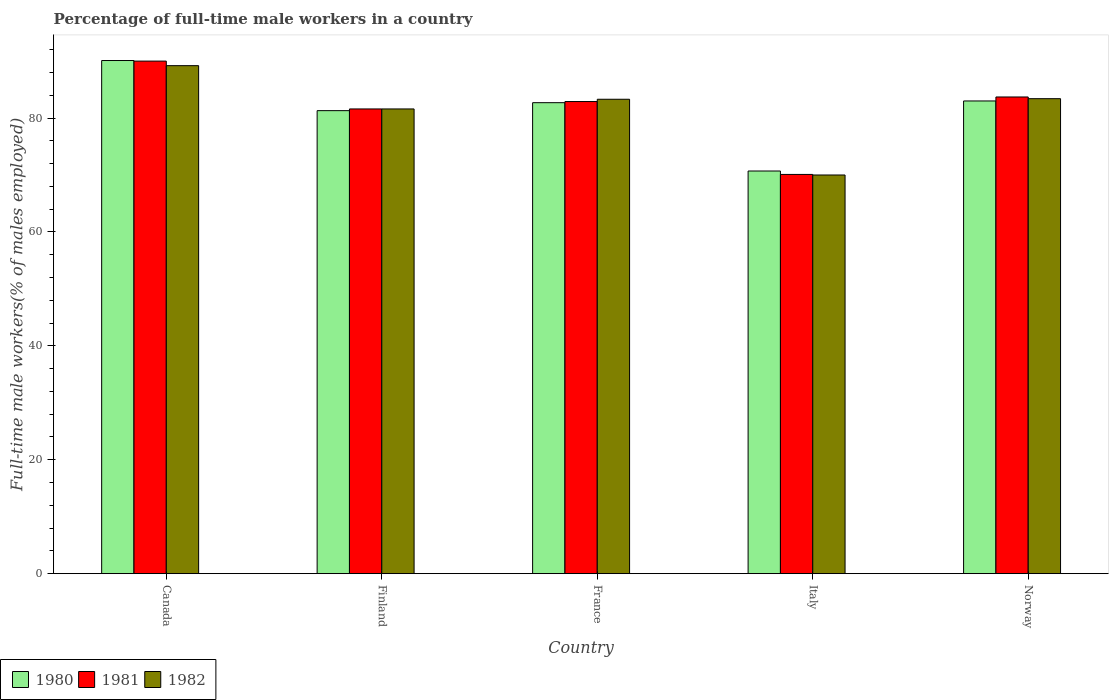How many groups of bars are there?
Your response must be concise. 5. Are the number of bars per tick equal to the number of legend labels?
Provide a succinct answer. Yes. Are the number of bars on each tick of the X-axis equal?
Provide a succinct answer. Yes. How many bars are there on the 1st tick from the right?
Give a very brief answer. 3. In how many cases, is the number of bars for a given country not equal to the number of legend labels?
Give a very brief answer. 0. What is the percentage of full-time male workers in 1982 in Canada?
Offer a very short reply. 89.2. Across all countries, what is the maximum percentage of full-time male workers in 1980?
Ensure brevity in your answer.  90.1. What is the total percentage of full-time male workers in 1980 in the graph?
Provide a short and direct response. 407.8. What is the difference between the percentage of full-time male workers in 1982 in Canada and that in Norway?
Offer a terse response. 5.8. What is the difference between the percentage of full-time male workers in 1981 in France and the percentage of full-time male workers in 1980 in Finland?
Give a very brief answer. 1.6. What is the average percentage of full-time male workers in 1980 per country?
Provide a short and direct response. 81.56. What is the difference between the percentage of full-time male workers of/in 1981 and percentage of full-time male workers of/in 1982 in Italy?
Make the answer very short. 0.1. In how many countries, is the percentage of full-time male workers in 1980 greater than 48 %?
Ensure brevity in your answer.  5. What is the ratio of the percentage of full-time male workers in 1980 in Finland to that in Italy?
Your response must be concise. 1.15. Is the percentage of full-time male workers in 1982 in Finland less than that in Norway?
Offer a very short reply. Yes. What is the difference between the highest and the second highest percentage of full-time male workers in 1980?
Offer a terse response. 7.1. What is the difference between the highest and the lowest percentage of full-time male workers in 1982?
Ensure brevity in your answer.  19.2. In how many countries, is the percentage of full-time male workers in 1981 greater than the average percentage of full-time male workers in 1981 taken over all countries?
Your answer should be very brief. 3. Is the sum of the percentage of full-time male workers in 1980 in Finland and Norway greater than the maximum percentage of full-time male workers in 1981 across all countries?
Provide a short and direct response. Yes. Is it the case that in every country, the sum of the percentage of full-time male workers in 1980 and percentage of full-time male workers in 1982 is greater than the percentage of full-time male workers in 1981?
Keep it short and to the point. Yes. Are all the bars in the graph horizontal?
Ensure brevity in your answer.  No. How many countries are there in the graph?
Offer a very short reply. 5. Does the graph contain grids?
Your answer should be compact. No. How many legend labels are there?
Ensure brevity in your answer.  3. How are the legend labels stacked?
Your response must be concise. Horizontal. What is the title of the graph?
Your answer should be compact. Percentage of full-time male workers in a country. What is the label or title of the X-axis?
Your answer should be very brief. Country. What is the label or title of the Y-axis?
Give a very brief answer. Full-time male workers(% of males employed). What is the Full-time male workers(% of males employed) in 1980 in Canada?
Your answer should be compact. 90.1. What is the Full-time male workers(% of males employed) in 1982 in Canada?
Ensure brevity in your answer.  89.2. What is the Full-time male workers(% of males employed) in 1980 in Finland?
Provide a short and direct response. 81.3. What is the Full-time male workers(% of males employed) in 1981 in Finland?
Make the answer very short. 81.6. What is the Full-time male workers(% of males employed) of 1982 in Finland?
Make the answer very short. 81.6. What is the Full-time male workers(% of males employed) of 1980 in France?
Your response must be concise. 82.7. What is the Full-time male workers(% of males employed) in 1981 in France?
Offer a very short reply. 82.9. What is the Full-time male workers(% of males employed) of 1982 in France?
Your answer should be compact. 83.3. What is the Full-time male workers(% of males employed) of 1980 in Italy?
Your answer should be compact. 70.7. What is the Full-time male workers(% of males employed) in 1981 in Italy?
Provide a succinct answer. 70.1. What is the Full-time male workers(% of males employed) in 1982 in Italy?
Ensure brevity in your answer.  70. What is the Full-time male workers(% of males employed) of 1981 in Norway?
Offer a very short reply. 83.7. What is the Full-time male workers(% of males employed) in 1982 in Norway?
Give a very brief answer. 83.4. Across all countries, what is the maximum Full-time male workers(% of males employed) in 1980?
Offer a terse response. 90.1. Across all countries, what is the maximum Full-time male workers(% of males employed) in 1982?
Keep it short and to the point. 89.2. Across all countries, what is the minimum Full-time male workers(% of males employed) in 1980?
Keep it short and to the point. 70.7. Across all countries, what is the minimum Full-time male workers(% of males employed) in 1981?
Give a very brief answer. 70.1. What is the total Full-time male workers(% of males employed) in 1980 in the graph?
Offer a very short reply. 407.8. What is the total Full-time male workers(% of males employed) of 1981 in the graph?
Ensure brevity in your answer.  408.3. What is the total Full-time male workers(% of males employed) of 1982 in the graph?
Make the answer very short. 407.5. What is the difference between the Full-time male workers(% of males employed) in 1980 in Canada and that in Finland?
Provide a succinct answer. 8.8. What is the difference between the Full-time male workers(% of males employed) of 1981 in Canada and that in Finland?
Make the answer very short. 8.4. What is the difference between the Full-time male workers(% of males employed) in 1981 in Canada and that in France?
Provide a succinct answer. 7.1. What is the difference between the Full-time male workers(% of males employed) in 1982 in Canada and that in France?
Ensure brevity in your answer.  5.9. What is the difference between the Full-time male workers(% of males employed) of 1982 in Finland and that in France?
Your answer should be very brief. -1.7. What is the difference between the Full-time male workers(% of males employed) in 1980 in Finland and that in Italy?
Ensure brevity in your answer.  10.6. What is the difference between the Full-time male workers(% of males employed) in 1982 in Finland and that in Italy?
Your answer should be very brief. 11.6. What is the difference between the Full-time male workers(% of males employed) of 1980 in Finland and that in Norway?
Offer a very short reply. -1.7. What is the difference between the Full-time male workers(% of males employed) in 1981 in Finland and that in Norway?
Keep it short and to the point. -2.1. What is the difference between the Full-time male workers(% of males employed) in 1982 in Finland and that in Norway?
Keep it short and to the point. -1.8. What is the difference between the Full-time male workers(% of males employed) of 1980 in France and that in Italy?
Your answer should be compact. 12. What is the difference between the Full-time male workers(% of males employed) in 1982 in France and that in Italy?
Your response must be concise. 13.3. What is the difference between the Full-time male workers(% of males employed) of 1980 in Italy and that in Norway?
Keep it short and to the point. -12.3. What is the difference between the Full-time male workers(% of males employed) in 1982 in Italy and that in Norway?
Provide a short and direct response. -13.4. What is the difference between the Full-time male workers(% of males employed) in 1980 in Canada and the Full-time male workers(% of males employed) in 1981 in France?
Offer a very short reply. 7.2. What is the difference between the Full-time male workers(% of males employed) in 1980 in Canada and the Full-time male workers(% of males employed) in 1982 in France?
Provide a short and direct response. 6.8. What is the difference between the Full-time male workers(% of males employed) in 1981 in Canada and the Full-time male workers(% of males employed) in 1982 in France?
Keep it short and to the point. 6.7. What is the difference between the Full-time male workers(% of males employed) in 1980 in Canada and the Full-time male workers(% of males employed) in 1981 in Italy?
Offer a terse response. 20. What is the difference between the Full-time male workers(% of males employed) of 1980 in Canada and the Full-time male workers(% of males employed) of 1982 in Italy?
Your response must be concise. 20.1. What is the difference between the Full-time male workers(% of males employed) in 1981 in Canada and the Full-time male workers(% of males employed) in 1982 in Norway?
Offer a terse response. 6.6. What is the difference between the Full-time male workers(% of males employed) of 1980 in Finland and the Full-time male workers(% of males employed) of 1982 in France?
Make the answer very short. -2. What is the difference between the Full-time male workers(% of males employed) in 1980 in Finland and the Full-time male workers(% of males employed) in 1982 in Italy?
Provide a succinct answer. 11.3. What is the difference between the Full-time male workers(% of males employed) in 1981 in Finland and the Full-time male workers(% of males employed) in 1982 in Norway?
Give a very brief answer. -1.8. What is the difference between the Full-time male workers(% of males employed) in 1980 in France and the Full-time male workers(% of males employed) in 1982 in Italy?
Your answer should be very brief. 12.7. What is the difference between the Full-time male workers(% of males employed) in 1981 in France and the Full-time male workers(% of males employed) in 1982 in Italy?
Your response must be concise. 12.9. What is the difference between the Full-time male workers(% of males employed) in 1980 in France and the Full-time male workers(% of males employed) in 1982 in Norway?
Provide a short and direct response. -0.7. What is the average Full-time male workers(% of males employed) in 1980 per country?
Ensure brevity in your answer.  81.56. What is the average Full-time male workers(% of males employed) in 1981 per country?
Provide a succinct answer. 81.66. What is the average Full-time male workers(% of males employed) in 1982 per country?
Give a very brief answer. 81.5. What is the difference between the Full-time male workers(% of males employed) of 1980 and Full-time male workers(% of males employed) of 1981 in Canada?
Offer a terse response. 0.1. What is the difference between the Full-time male workers(% of males employed) of 1980 and Full-time male workers(% of males employed) of 1982 in Canada?
Your response must be concise. 0.9. What is the difference between the Full-time male workers(% of males employed) in 1981 and Full-time male workers(% of males employed) in 1982 in Canada?
Ensure brevity in your answer.  0.8. What is the difference between the Full-time male workers(% of males employed) in 1980 and Full-time male workers(% of males employed) in 1981 in Finland?
Your answer should be very brief. -0.3. What is the difference between the Full-time male workers(% of males employed) of 1981 and Full-time male workers(% of males employed) of 1982 in Finland?
Provide a succinct answer. 0. What is the difference between the Full-time male workers(% of males employed) in 1980 and Full-time male workers(% of males employed) in 1981 in France?
Make the answer very short. -0.2. What is the difference between the Full-time male workers(% of males employed) of 1980 and Full-time male workers(% of males employed) of 1981 in Italy?
Give a very brief answer. 0.6. What is the difference between the Full-time male workers(% of males employed) in 1980 and Full-time male workers(% of males employed) in 1981 in Norway?
Provide a succinct answer. -0.7. What is the ratio of the Full-time male workers(% of males employed) in 1980 in Canada to that in Finland?
Keep it short and to the point. 1.11. What is the ratio of the Full-time male workers(% of males employed) of 1981 in Canada to that in Finland?
Your answer should be compact. 1.1. What is the ratio of the Full-time male workers(% of males employed) in 1982 in Canada to that in Finland?
Ensure brevity in your answer.  1.09. What is the ratio of the Full-time male workers(% of males employed) of 1980 in Canada to that in France?
Give a very brief answer. 1.09. What is the ratio of the Full-time male workers(% of males employed) of 1981 in Canada to that in France?
Make the answer very short. 1.09. What is the ratio of the Full-time male workers(% of males employed) in 1982 in Canada to that in France?
Make the answer very short. 1.07. What is the ratio of the Full-time male workers(% of males employed) of 1980 in Canada to that in Italy?
Offer a terse response. 1.27. What is the ratio of the Full-time male workers(% of males employed) of 1981 in Canada to that in Italy?
Keep it short and to the point. 1.28. What is the ratio of the Full-time male workers(% of males employed) of 1982 in Canada to that in Italy?
Offer a terse response. 1.27. What is the ratio of the Full-time male workers(% of males employed) of 1980 in Canada to that in Norway?
Give a very brief answer. 1.09. What is the ratio of the Full-time male workers(% of males employed) in 1981 in Canada to that in Norway?
Make the answer very short. 1.08. What is the ratio of the Full-time male workers(% of males employed) of 1982 in Canada to that in Norway?
Provide a short and direct response. 1.07. What is the ratio of the Full-time male workers(% of males employed) of 1980 in Finland to that in France?
Make the answer very short. 0.98. What is the ratio of the Full-time male workers(% of males employed) of 1981 in Finland to that in France?
Offer a terse response. 0.98. What is the ratio of the Full-time male workers(% of males employed) of 1982 in Finland to that in France?
Keep it short and to the point. 0.98. What is the ratio of the Full-time male workers(% of males employed) of 1980 in Finland to that in Italy?
Give a very brief answer. 1.15. What is the ratio of the Full-time male workers(% of males employed) of 1981 in Finland to that in Italy?
Give a very brief answer. 1.16. What is the ratio of the Full-time male workers(% of males employed) in 1982 in Finland to that in Italy?
Offer a very short reply. 1.17. What is the ratio of the Full-time male workers(% of males employed) in 1980 in Finland to that in Norway?
Offer a very short reply. 0.98. What is the ratio of the Full-time male workers(% of males employed) of 1981 in Finland to that in Norway?
Your answer should be compact. 0.97. What is the ratio of the Full-time male workers(% of males employed) of 1982 in Finland to that in Norway?
Provide a short and direct response. 0.98. What is the ratio of the Full-time male workers(% of males employed) in 1980 in France to that in Italy?
Your response must be concise. 1.17. What is the ratio of the Full-time male workers(% of males employed) in 1981 in France to that in Italy?
Make the answer very short. 1.18. What is the ratio of the Full-time male workers(% of males employed) in 1982 in France to that in Italy?
Provide a succinct answer. 1.19. What is the ratio of the Full-time male workers(% of males employed) in 1980 in France to that in Norway?
Offer a terse response. 1. What is the ratio of the Full-time male workers(% of males employed) of 1982 in France to that in Norway?
Provide a succinct answer. 1. What is the ratio of the Full-time male workers(% of males employed) of 1980 in Italy to that in Norway?
Offer a very short reply. 0.85. What is the ratio of the Full-time male workers(% of males employed) in 1981 in Italy to that in Norway?
Your answer should be compact. 0.84. What is the ratio of the Full-time male workers(% of males employed) of 1982 in Italy to that in Norway?
Offer a terse response. 0.84. What is the difference between the highest and the second highest Full-time male workers(% of males employed) of 1980?
Keep it short and to the point. 7.1. What is the difference between the highest and the lowest Full-time male workers(% of males employed) in 1982?
Give a very brief answer. 19.2. 